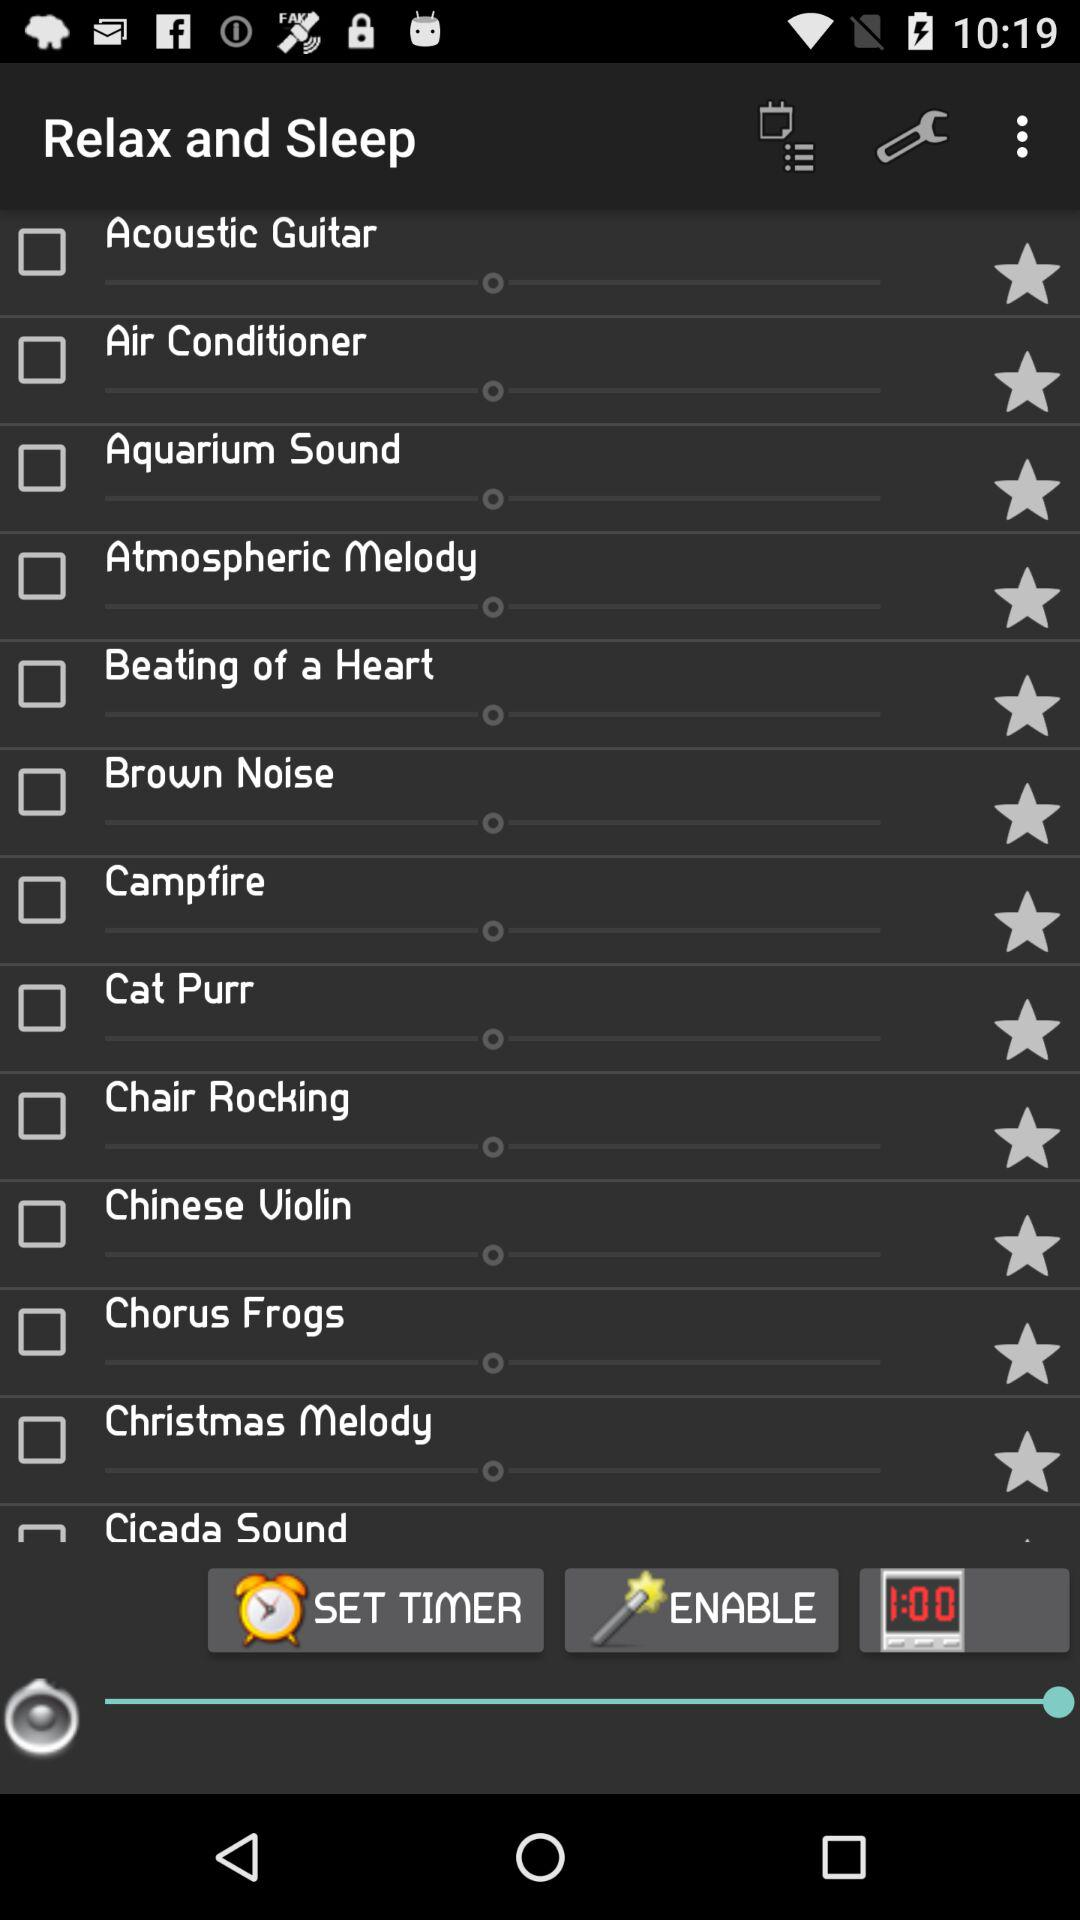What is the status of the "Acoustic Guitar"? The status is "off". 